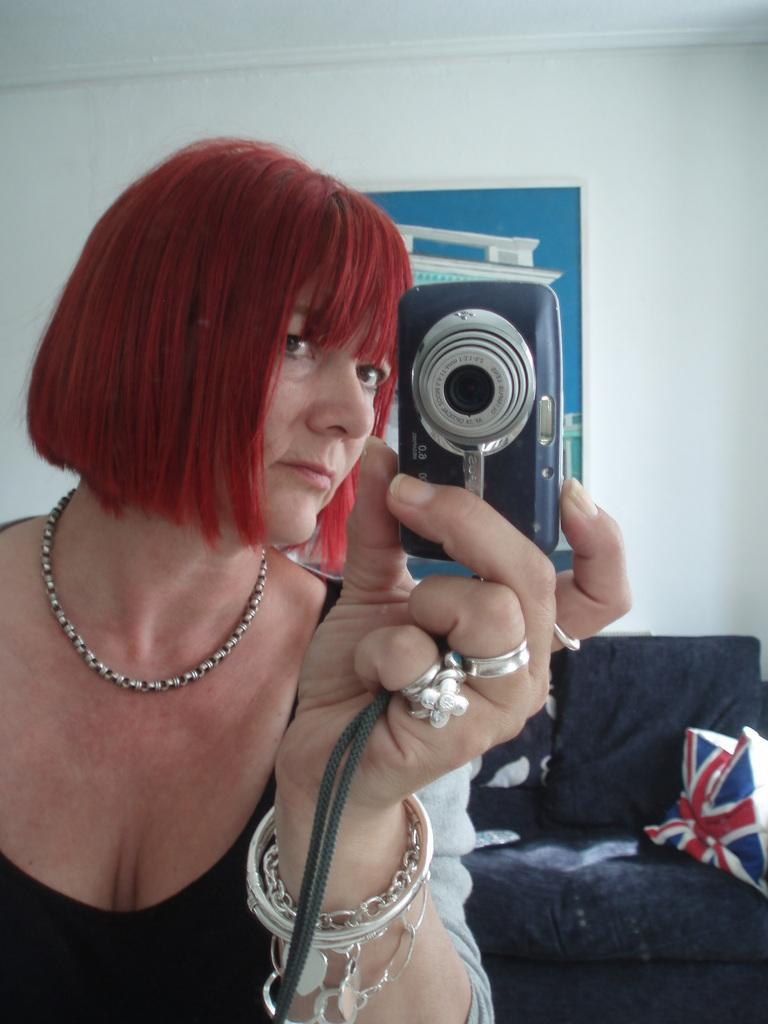Who is present in the image? There is a woman in the image. What is the woman holding in the image? The woman is holding a camera. What can be seen in the background of the image? There is a couch, a pillow, and a frame attached to a wall in the background of the image. What type of tank can be seen in the image? There is no tank present in the image. How many cubs are visible in the image? There are no cubs present in the image. 